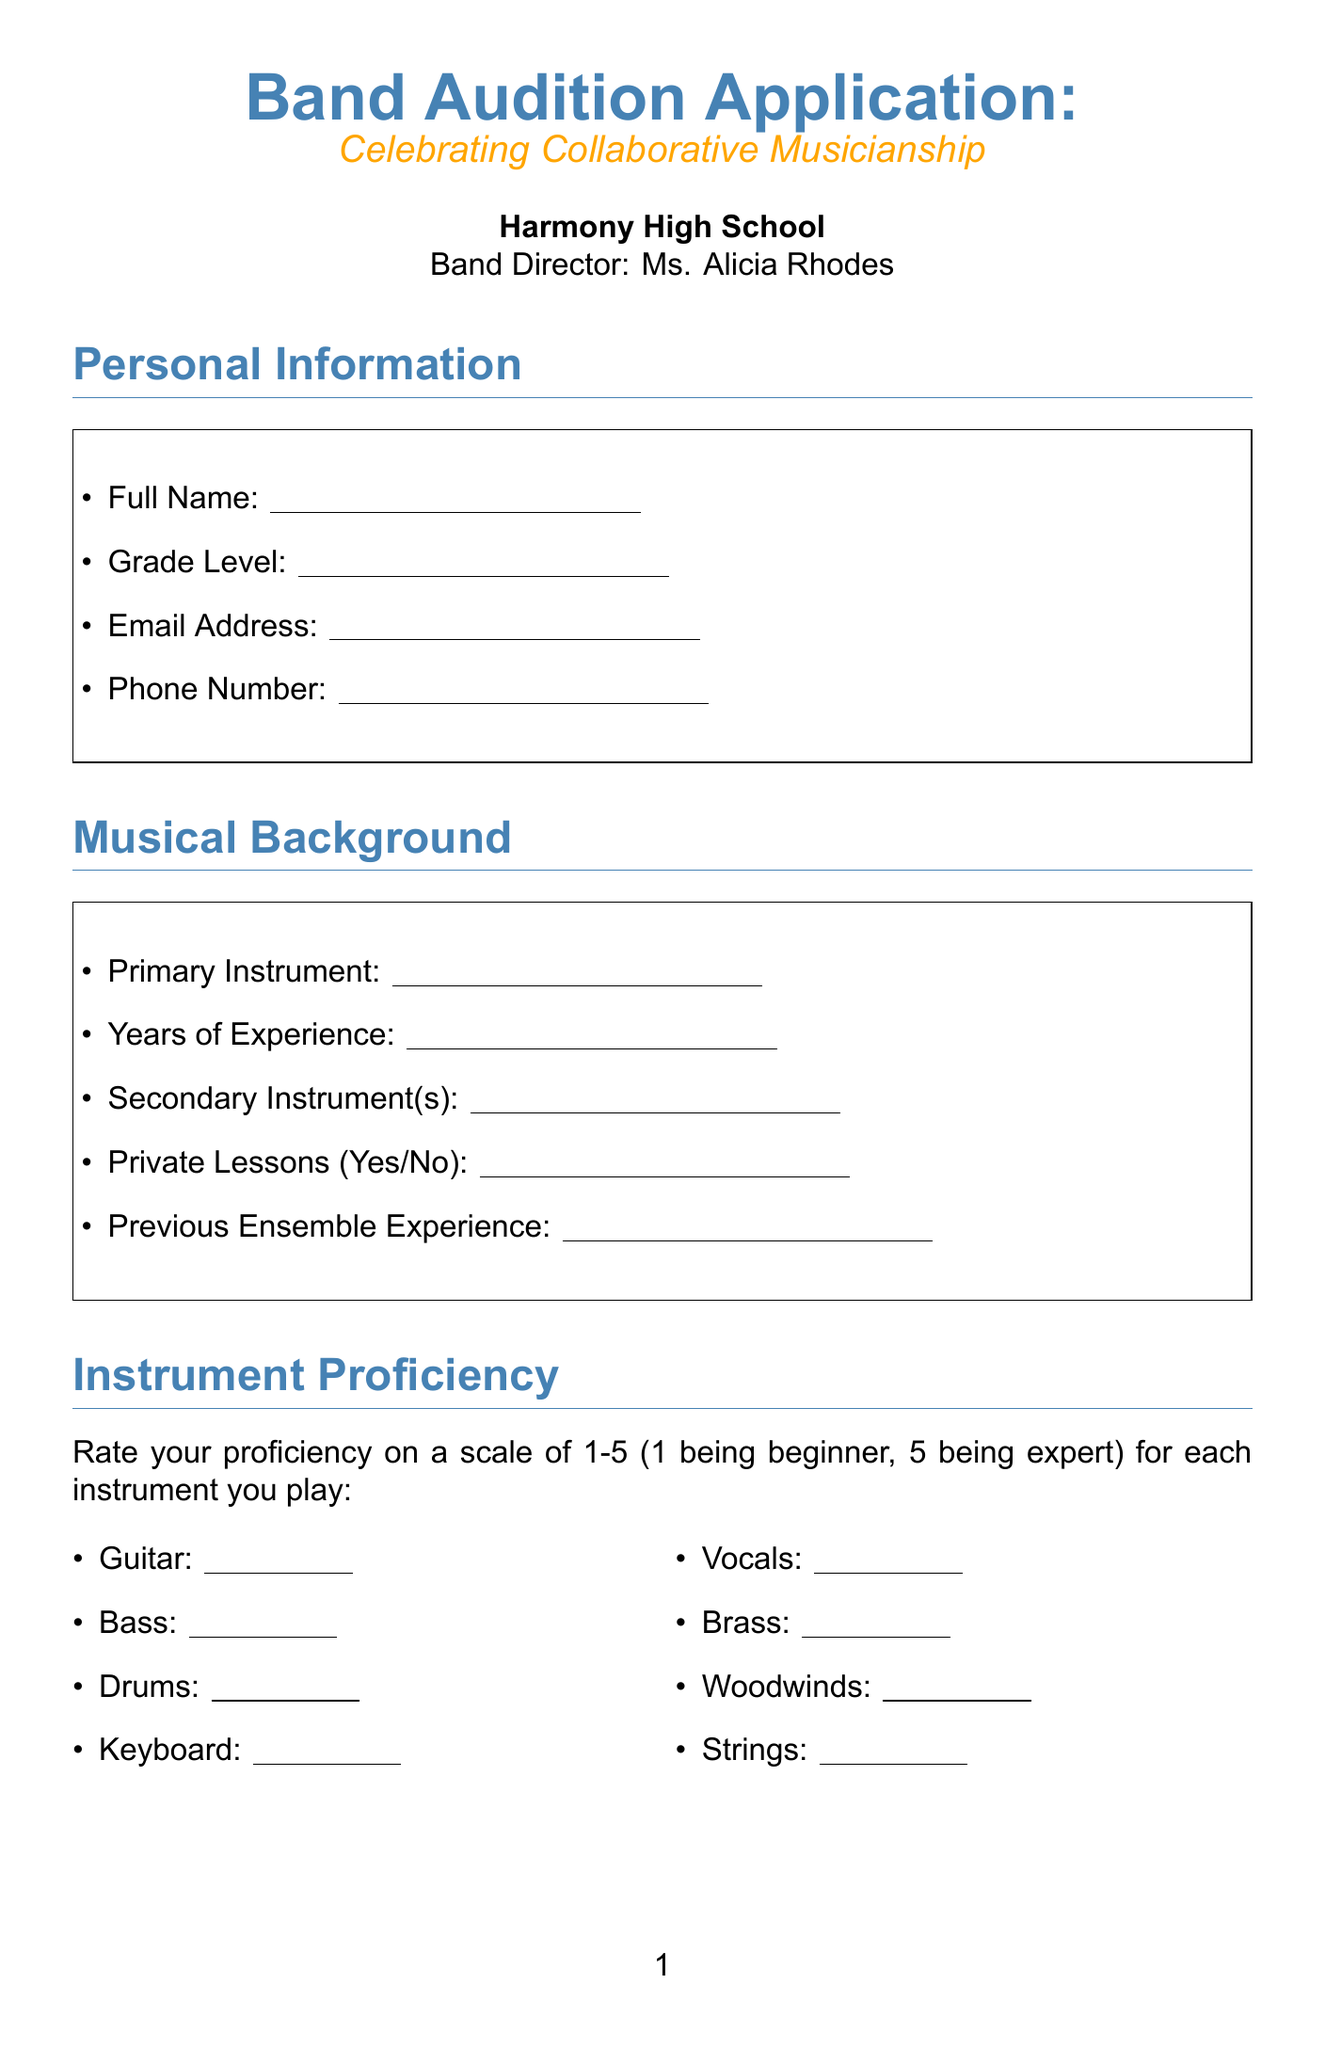What is the title of the form? The title of the form is clearly stated at the top of the document.
Answer: Band Audition Application: Celebrating Collaborative Musicianship Who is the band director? The document specifies the name of the band director under the school information section.
Answer: Ms. Alicia Rhodes What is one of the fields in the Personal Information section? This refers to the data requested from applicants in the Personal Information section of the document.
Answer: Full Name How many instruments are listed for proficiency rating? The document includes a specific section dedicated to rating proficiency on instruments.
Answer: Eight What is the purpose of the Collaborative Spirit section? This section aims to understand applicants' attitudes and experiences in teamwork in a musical context.
Answer: Handle constructive criticism What is an example of an additional skill listed? The document includes a checklist of skills that applicants may possess.
Answer: Music Theory Knowledge What should be included in the Audition Piece section? This section specifies what applicants need to prepare and describe regarding their audition.
Answer: Song Title What genre of music should applicants be interested in playing? This information is solicited from applicants as part of understanding their musical preferences.
Answer: (Any genre of music the applicant is interested in) What is a requirement stated in the declaration? The declaration outlines an important expectation for applicants if they wish to be part of the band.
Answer: Dedication and teamwork 